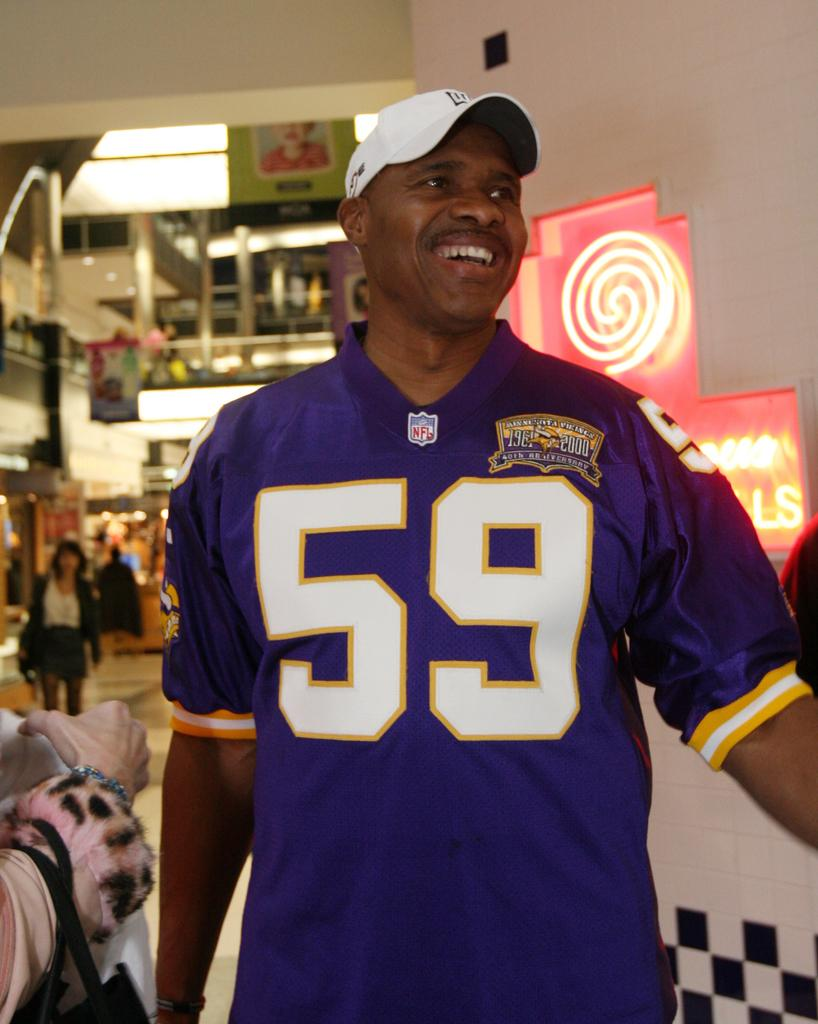<image>
Relay a brief, clear account of the picture shown. A smiling man wears a sports jersey with the number 59. 